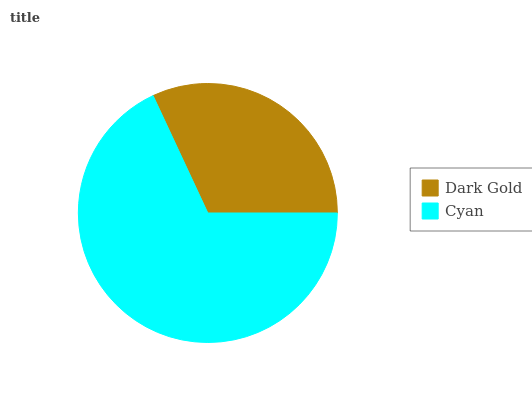Is Dark Gold the minimum?
Answer yes or no. Yes. Is Cyan the maximum?
Answer yes or no. Yes. Is Cyan the minimum?
Answer yes or no. No. Is Cyan greater than Dark Gold?
Answer yes or no. Yes. Is Dark Gold less than Cyan?
Answer yes or no. Yes. Is Dark Gold greater than Cyan?
Answer yes or no. No. Is Cyan less than Dark Gold?
Answer yes or no. No. Is Cyan the high median?
Answer yes or no. Yes. Is Dark Gold the low median?
Answer yes or no. Yes. Is Dark Gold the high median?
Answer yes or no. No. Is Cyan the low median?
Answer yes or no. No. 